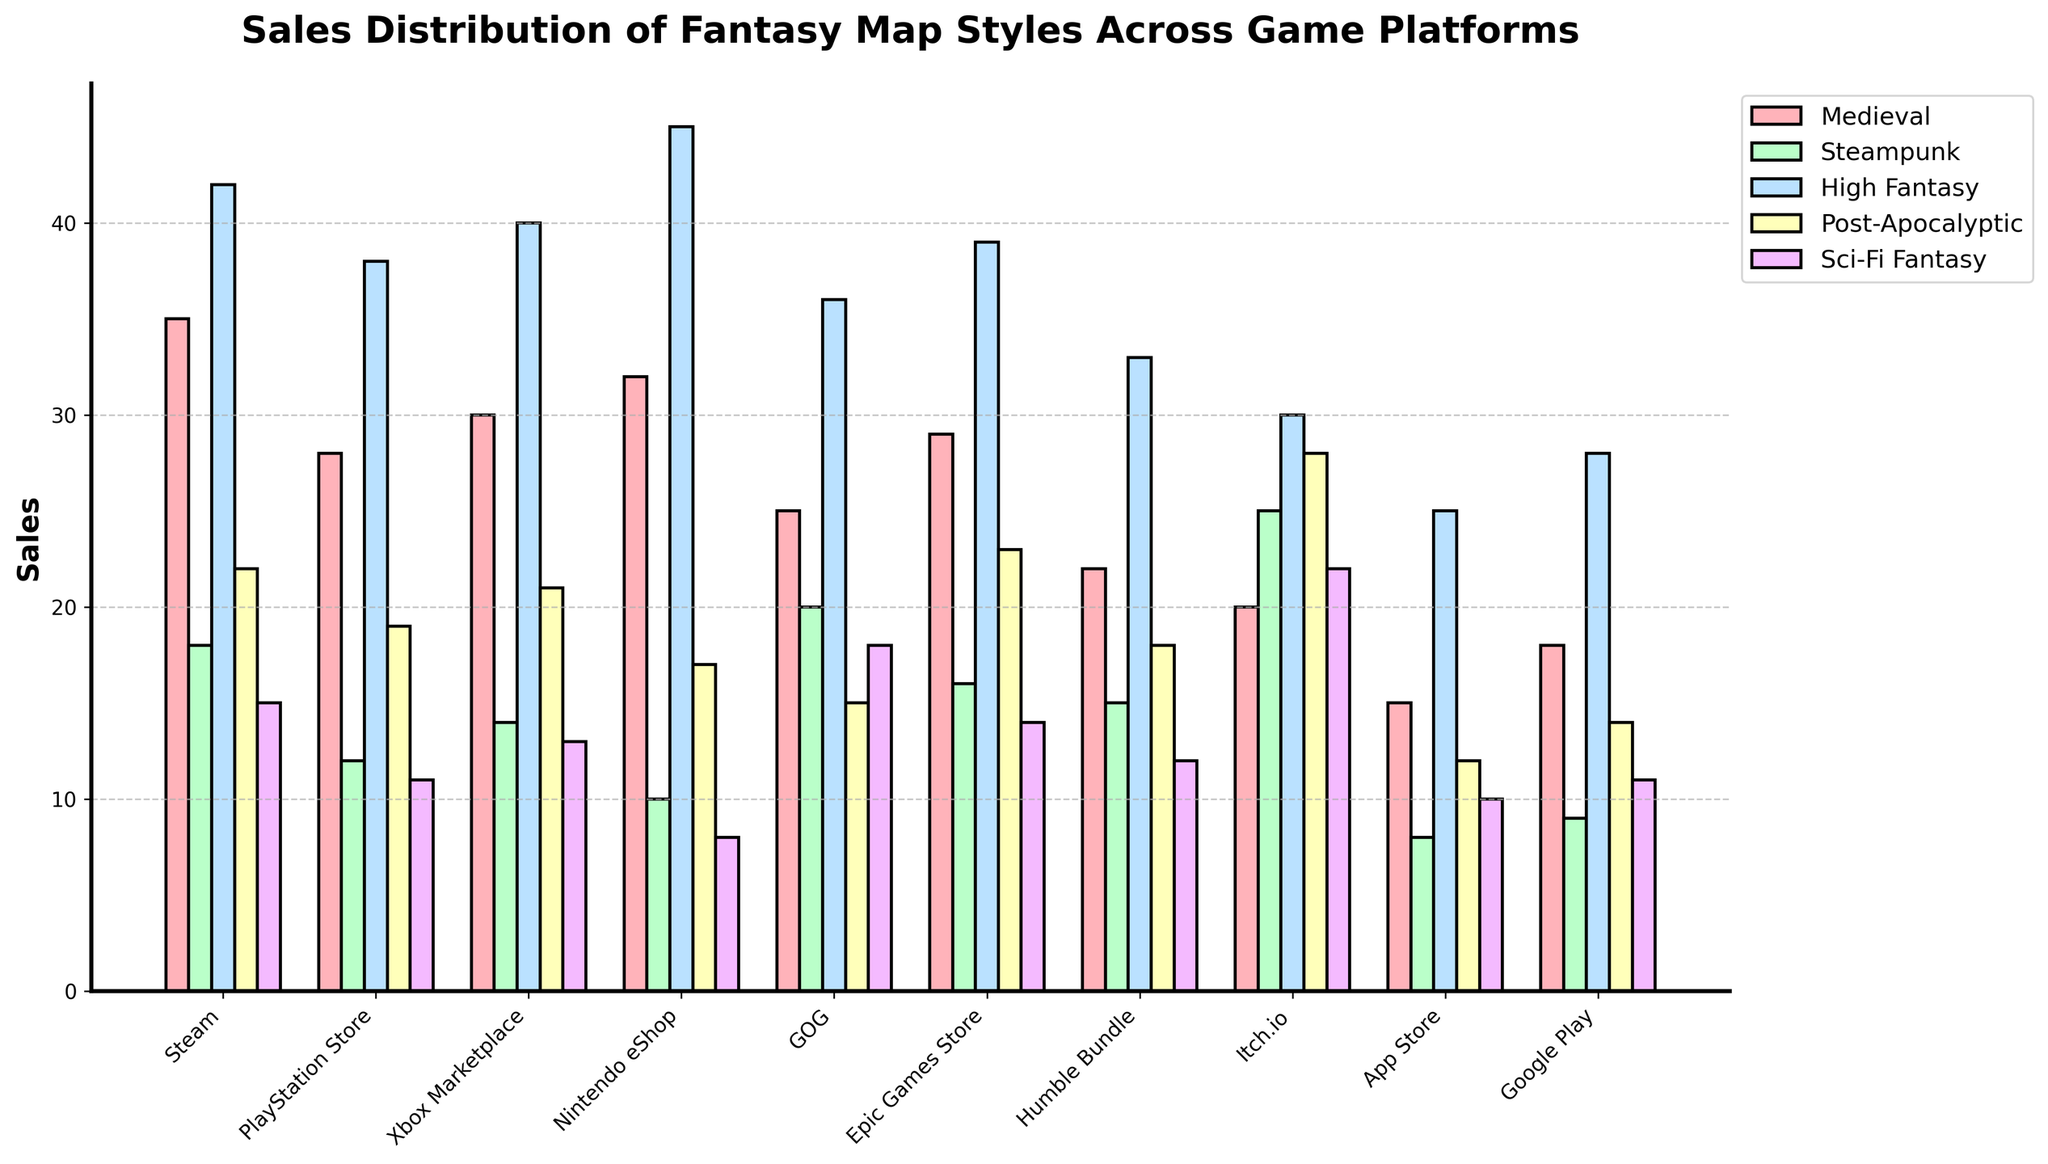Which game platform has the highest sales in the "High Fantasy" style? By looking at the "High Fantasy" bars on the chart, the highest bar corresponds to the "Nintendo eShop".
Answer: Nintendo eShop Which map style has the least sales on the "Google Play" platform? By inspecting the bars for each map style on "Google Play," the shortest bar corresponds to the "Medieval" style.
Answer: Medieval How do the "Steampunk" sales on "GOG" compare to the "Steampunk" sales on "Steam"? Compare the height of the "Steampunk" bars for both platforms. "GOG" has a height of 20 and "Steam" has a height of 18, meaning "GOG" has higher sales.
Answer: GOG has higher sales What is the combined sales total for "Post-Apocalyptic" style across all platforms? Sum the height of the "Post-Apocalyptic" bars for each platform: 22 (Steam) + 19 (PlayStation Store) + 21 (Xbox Marketplace) + 17 (Nintendo eShop) + 15 (GOG) + 23 (Epic Games Store) + 18 (Humble Bundle) + 28 (Itch.io) + 12 (App Store) + 14 (Google Play). The total is 189.
Answer: 189 Which platform shows a greater difference between "High Fantasy" and "Sci-Fi Fantasy" sales, "Epic Games Store" or "Steam"? Calculate the difference between "High Fantasy" and "Sci-Fi Fantasy" sales for both platforms: Epic Games Store (39 - 14 = 25) and Steam (42 - 15 = 27), and compare the results. Steam shows a greater difference.
Answer: Steam Which fantasy map style has the most consistent sales across all platforms? Evaluate the sales bar heights for each map style across all platforms and identify the style with the least variation in bar heights. "High Fantasy" appears to have consistently high sales across platforms.
Answer: High Fantasy Out of "Medieval" and "Sci-Fi Fantasy" styles, which has higher sales on "Itch.io"? Compare the bar heights for "Medieval" and "Sci-Fi Fantasy" on "Itch.io." The "Sci-Fi Fantasy" bar is taller than the "Medieval" bar.
Answer: Sci-Fi Fantasy What is the average sales of the "Medieval" style across all game platforms? Calculate the sum of "Medieval" sales across all platforms: 35 (Steam) + 28 (PlayStation Store) + 30 (Xbox Marketplace) + 32 (Nintendo eShop) + 25 (GOG) + 29 (Epic Games Store) + 22 (Humble Bundle) + 20 (Itch.io) + 15 (App Store) + 18 (Google Play) = 254. There are 10 platforms, so the average is 254 / 10 = 25.4.
Answer: 25.4 Which platform shows the least variation between the highest and lowest sales of any map styles? Calculate the range (highest - lowest sales) for each platform, then compare the ranges to identify the smallest. GOG has the least variation in sales (36 - 15 = 21).
Answer: GOG 